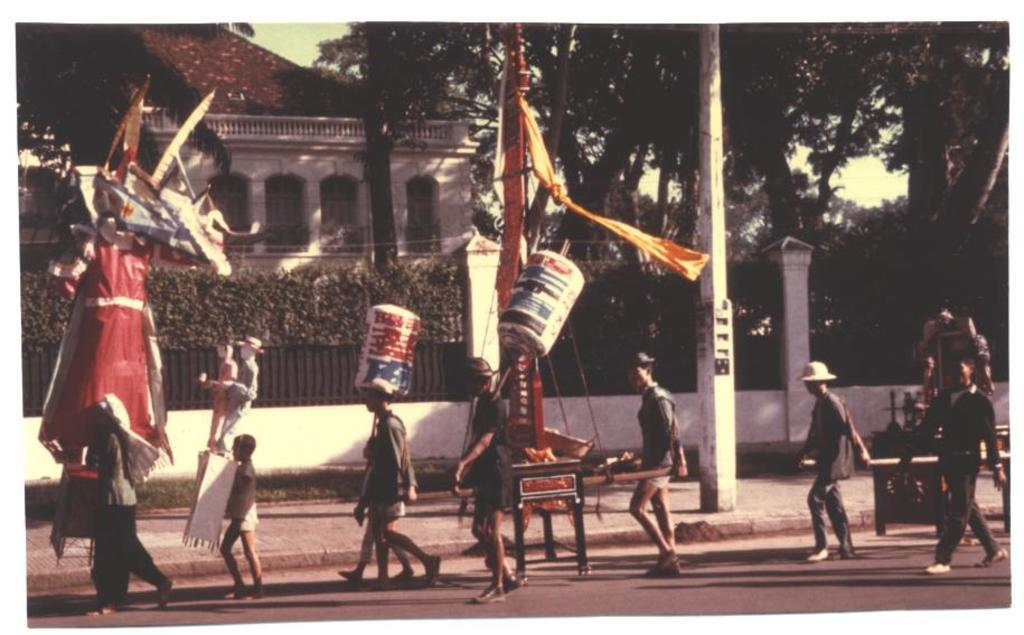What is happening with the group of people in the image? The people are walking on the road in the image. What can be seen in the background of the image? There are poles, a white-colored building, green-colored trees, and the sky visible in the background. What is the color of the sky in the image? The sky appears to be white in the image. What type of board is being used by the people to walk on the road? There is no board present in the image; the people are walking on the road itself. What is the arm of the tree doing in the image? There is no specific mention of an arm of a tree in the image, and trees are mentioned as being in the background. 